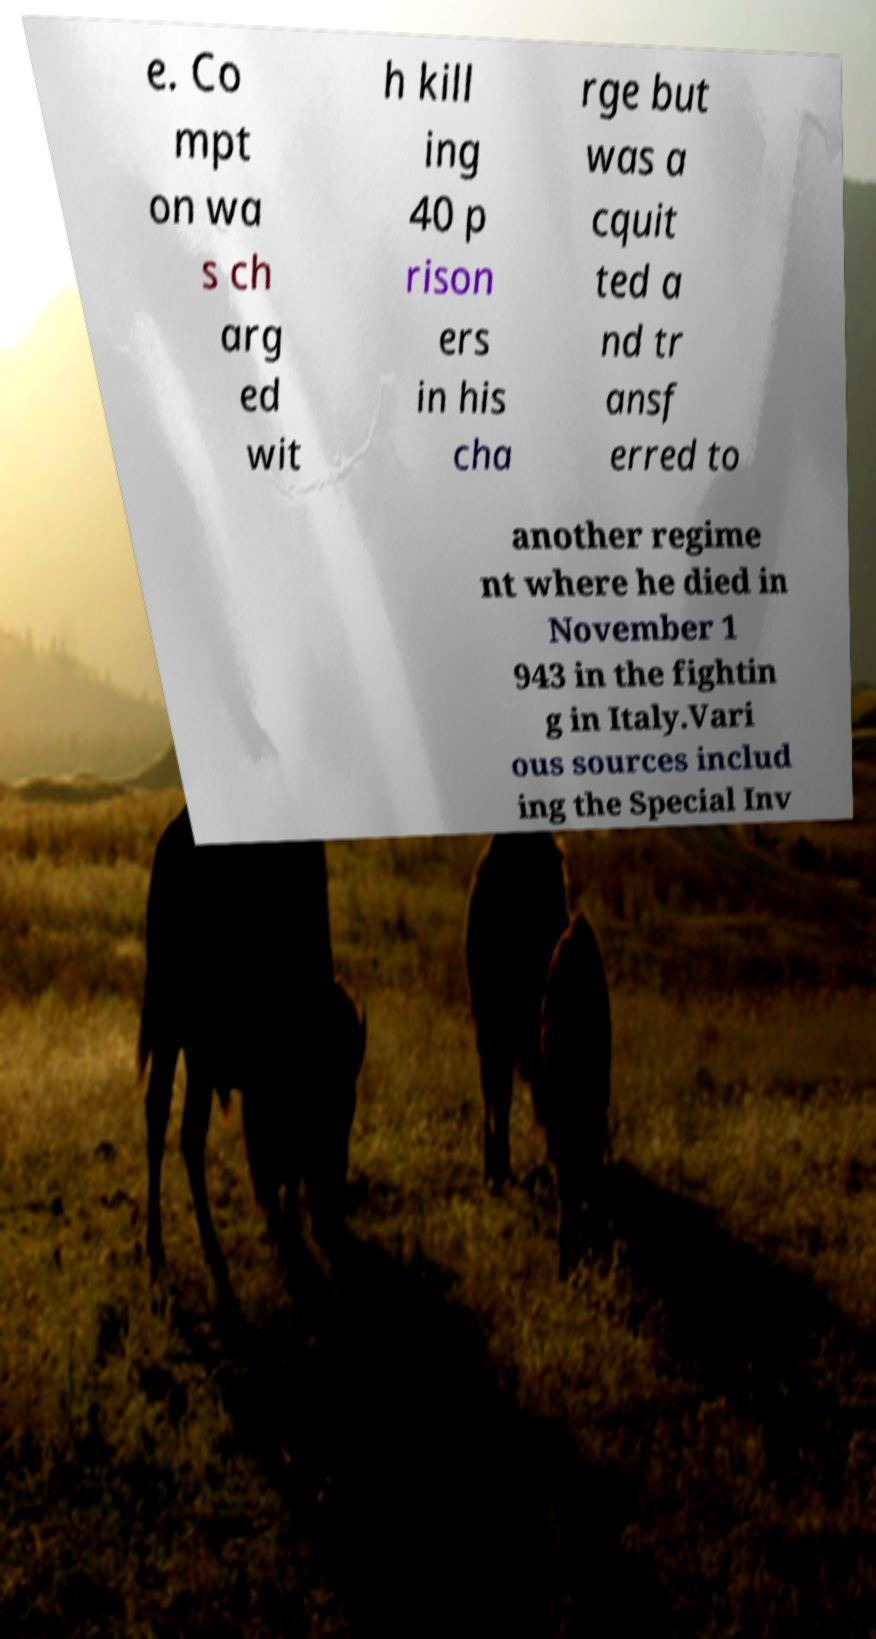Could you assist in decoding the text presented in this image and type it out clearly? e. Co mpt on wa s ch arg ed wit h kill ing 40 p rison ers in his cha rge but was a cquit ted a nd tr ansf erred to another regime nt where he died in November 1 943 in the fightin g in Italy.Vari ous sources includ ing the Special Inv 